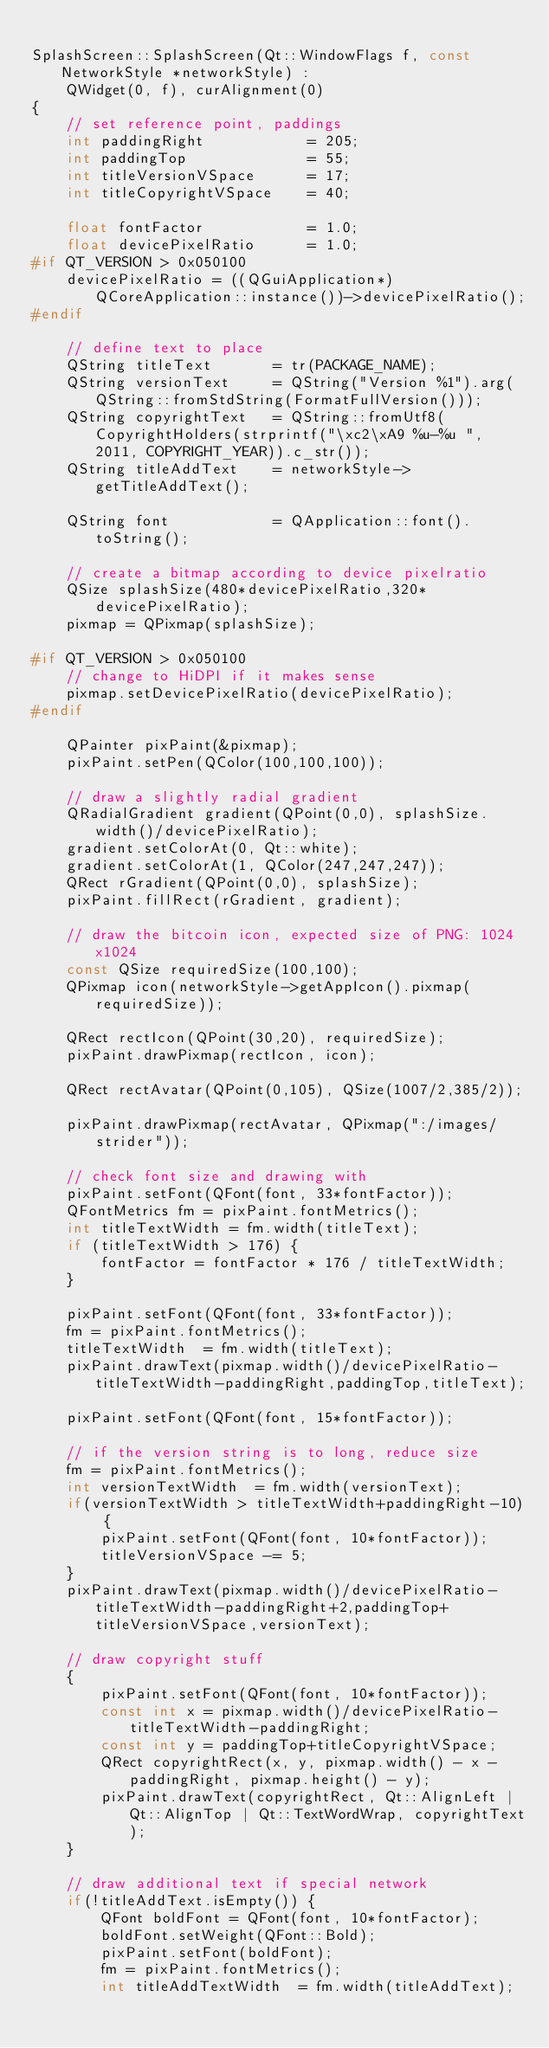Convert code to text. <code><loc_0><loc_0><loc_500><loc_500><_C++_>
SplashScreen::SplashScreen(Qt::WindowFlags f, const NetworkStyle *networkStyle) :
    QWidget(0, f), curAlignment(0)
{
    // set reference point, paddings
    int paddingRight            = 205;
    int paddingTop              = 55;
    int titleVersionVSpace      = 17;
    int titleCopyrightVSpace    = 40;

    float fontFactor            = 1.0;
    float devicePixelRatio      = 1.0;
#if QT_VERSION > 0x050100
    devicePixelRatio = ((QGuiApplication*)QCoreApplication::instance())->devicePixelRatio();
#endif

    // define text to place
    QString titleText       = tr(PACKAGE_NAME);
    QString versionText     = QString("Version %1").arg(QString::fromStdString(FormatFullVersion()));
    QString copyrightText   = QString::fromUtf8(CopyrightHolders(strprintf("\xc2\xA9 %u-%u ", 2011, COPYRIGHT_YEAR)).c_str());
    QString titleAddText    = networkStyle->getTitleAddText();

    QString font            = QApplication::font().toString();

    // create a bitmap according to device pixelratio
    QSize splashSize(480*devicePixelRatio,320*devicePixelRatio);
    pixmap = QPixmap(splashSize);

#if QT_VERSION > 0x050100
    // change to HiDPI if it makes sense
    pixmap.setDevicePixelRatio(devicePixelRatio);
#endif

    QPainter pixPaint(&pixmap);
    pixPaint.setPen(QColor(100,100,100));

    // draw a slightly radial gradient
    QRadialGradient gradient(QPoint(0,0), splashSize.width()/devicePixelRatio);
    gradient.setColorAt(0, Qt::white);
    gradient.setColorAt(1, QColor(247,247,247));
    QRect rGradient(QPoint(0,0), splashSize);
    pixPaint.fillRect(rGradient, gradient);

    // draw the bitcoin icon, expected size of PNG: 1024x1024
    const QSize requiredSize(100,100);
    QPixmap icon(networkStyle->getAppIcon().pixmap(requiredSize));

    QRect rectIcon(QPoint(30,20), requiredSize);
    pixPaint.drawPixmap(rectIcon, icon);

    QRect rectAvatar(QPoint(0,105), QSize(1007/2,385/2));

    pixPaint.drawPixmap(rectAvatar, QPixmap(":/images/strider"));

    // check font size and drawing with
    pixPaint.setFont(QFont(font, 33*fontFactor));
    QFontMetrics fm = pixPaint.fontMetrics();
    int titleTextWidth = fm.width(titleText);
    if (titleTextWidth > 176) {
        fontFactor = fontFactor * 176 / titleTextWidth;
    }

    pixPaint.setFont(QFont(font, 33*fontFactor));
    fm = pixPaint.fontMetrics();
    titleTextWidth  = fm.width(titleText);
    pixPaint.drawText(pixmap.width()/devicePixelRatio-titleTextWidth-paddingRight,paddingTop,titleText);

    pixPaint.setFont(QFont(font, 15*fontFactor));

    // if the version string is to long, reduce size
    fm = pixPaint.fontMetrics();
    int versionTextWidth  = fm.width(versionText);
    if(versionTextWidth > titleTextWidth+paddingRight-10) {
        pixPaint.setFont(QFont(font, 10*fontFactor));
        titleVersionVSpace -= 5;
    }
    pixPaint.drawText(pixmap.width()/devicePixelRatio-titleTextWidth-paddingRight+2,paddingTop+titleVersionVSpace,versionText);

    // draw copyright stuff
    {
        pixPaint.setFont(QFont(font, 10*fontFactor));
        const int x = pixmap.width()/devicePixelRatio-titleTextWidth-paddingRight;
        const int y = paddingTop+titleCopyrightVSpace;
        QRect copyrightRect(x, y, pixmap.width() - x - paddingRight, pixmap.height() - y);
        pixPaint.drawText(copyrightRect, Qt::AlignLeft | Qt::AlignTop | Qt::TextWordWrap, copyrightText);
    }

    // draw additional text if special network
    if(!titleAddText.isEmpty()) {
        QFont boldFont = QFont(font, 10*fontFactor);
        boldFont.setWeight(QFont::Bold);
        pixPaint.setFont(boldFont);
        fm = pixPaint.fontMetrics();
        int titleAddTextWidth  = fm.width(titleAddText);</code> 